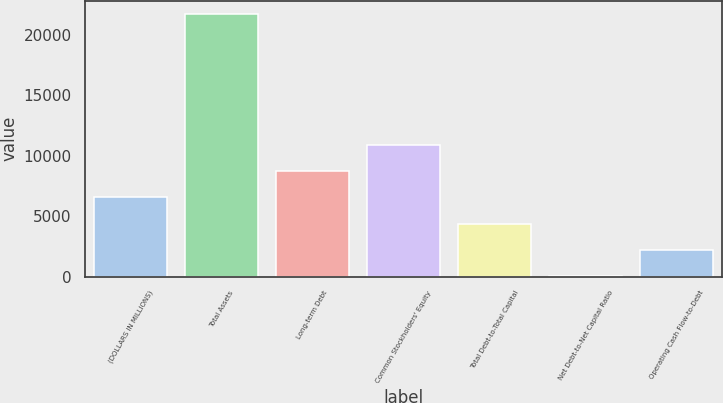Convert chart. <chart><loc_0><loc_0><loc_500><loc_500><bar_chart><fcel>(DOLLARS IN MILLIONS)<fcel>Total Assets<fcel>Long-term Debt<fcel>Common Stockholders' Equity<fcel>Total Debt-to-Total Capital<fcel>Net Debt-to-Net Capital Ratio<fcel>Operating Cash Flow-to-Debt<nl><fcel>6541.51<fcel>21732<fcel>8711.58<fcel>10881.6<fcel>4371.44<fcel>31.3<fcel>2201.37<nl></chart> 